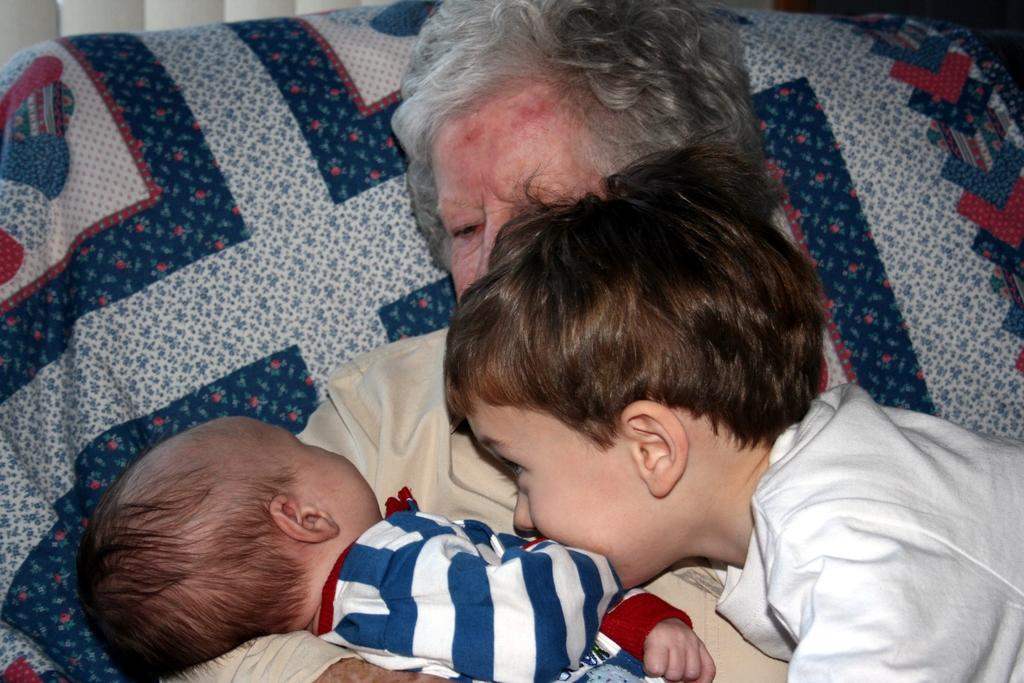What is the main subject of the image? The main subject of the image is the persons in the center. Can you describe the background of the image? There is a pillow in the background of the image. What is the pillow covered with? The pillow is covered with a blue-coloured bed sheet. What type of wood can be seen in the image? There is no wood visible in the image. Is there a birthday celebration happening in the image? There is no indication of a birthday celebration in the image. 